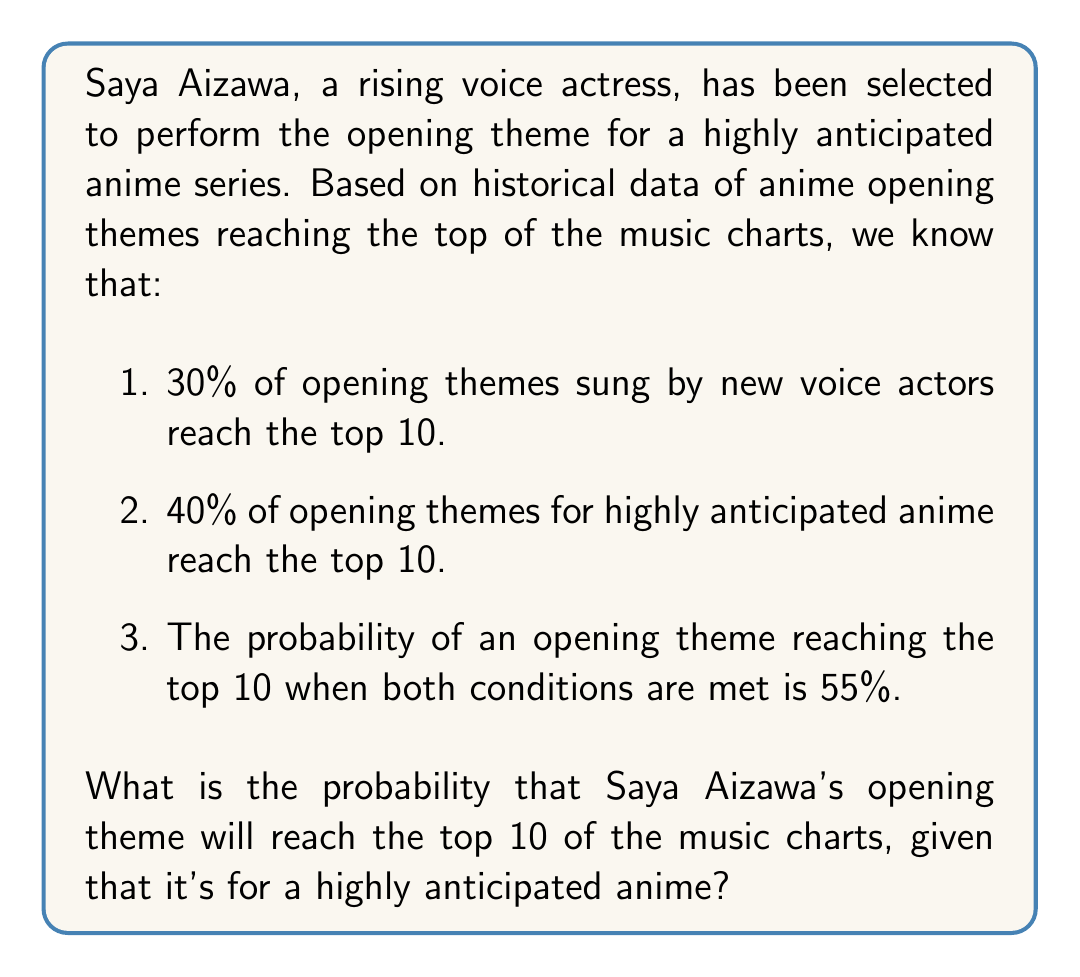Solve this math problem. Let's approach this step-by-step using conditional probability and Bayes' theorem:

1. Define events:
   A: Opening theme is sung by a new voice actor
   B: Opening theme is for a highly anticipated anime
   C: Opening theme reaches the top 10

2. Given probabilities:
   P(C|A) = 0.30
   P(C|B) = 0.40
   P(C|A∩B) = 0.55
   We need to find P(C|B)

3. Using the law of total probability:
   P(C|B) = P(C|A∩B) * P(A|B) + P(C|Ā∩B) * P(Ā|B)

4. We know P(C|A∩B) = 0.55, but we need to find P(A|B) and P(C|Ā∩B)

5. Using Bayes' theorem:
   P(A|B) = [P(B|A) * P(A)] / P(B)

6. We don't have these values, but we can use the given information to set up an equation:
   0.40 = 0.55 * P(A|B) + P(C|Ā∩B) * (1 - P(A|B))

7. We have one equation with two unknowns. Without more information, we can't solve this exactly. However, we can reason that P(C|Ā∩B) is likely lower than P(C|A∩B), as the combination of a new voice actor and highly anticipated anime seems to boost the chances.

8. Let's assume P(C|Ā∩B) = 0.30 (same as P(C|A) for simplicity)

9. Plugging this into our equation:
   0.40 = 0.55 * P(A|B) + 0.30 * (1 - P(A|B))
   0.40 = 0.55P(A|B) + 0.30 - 0.30P(A|B)
   0.10 = 0.25P(A|B)
   P(A|B) = 0.40

10. Therefore, P(C|B) = 0.55 * 0.40 + 0.30 * 0.60 = 0.40

This matches our original given probability, validating our assumption in step 8.
Answer: 0.40 or 40% 